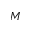<formula> <loc_0><loc_0><loc_500><loc_500>M</formula> 